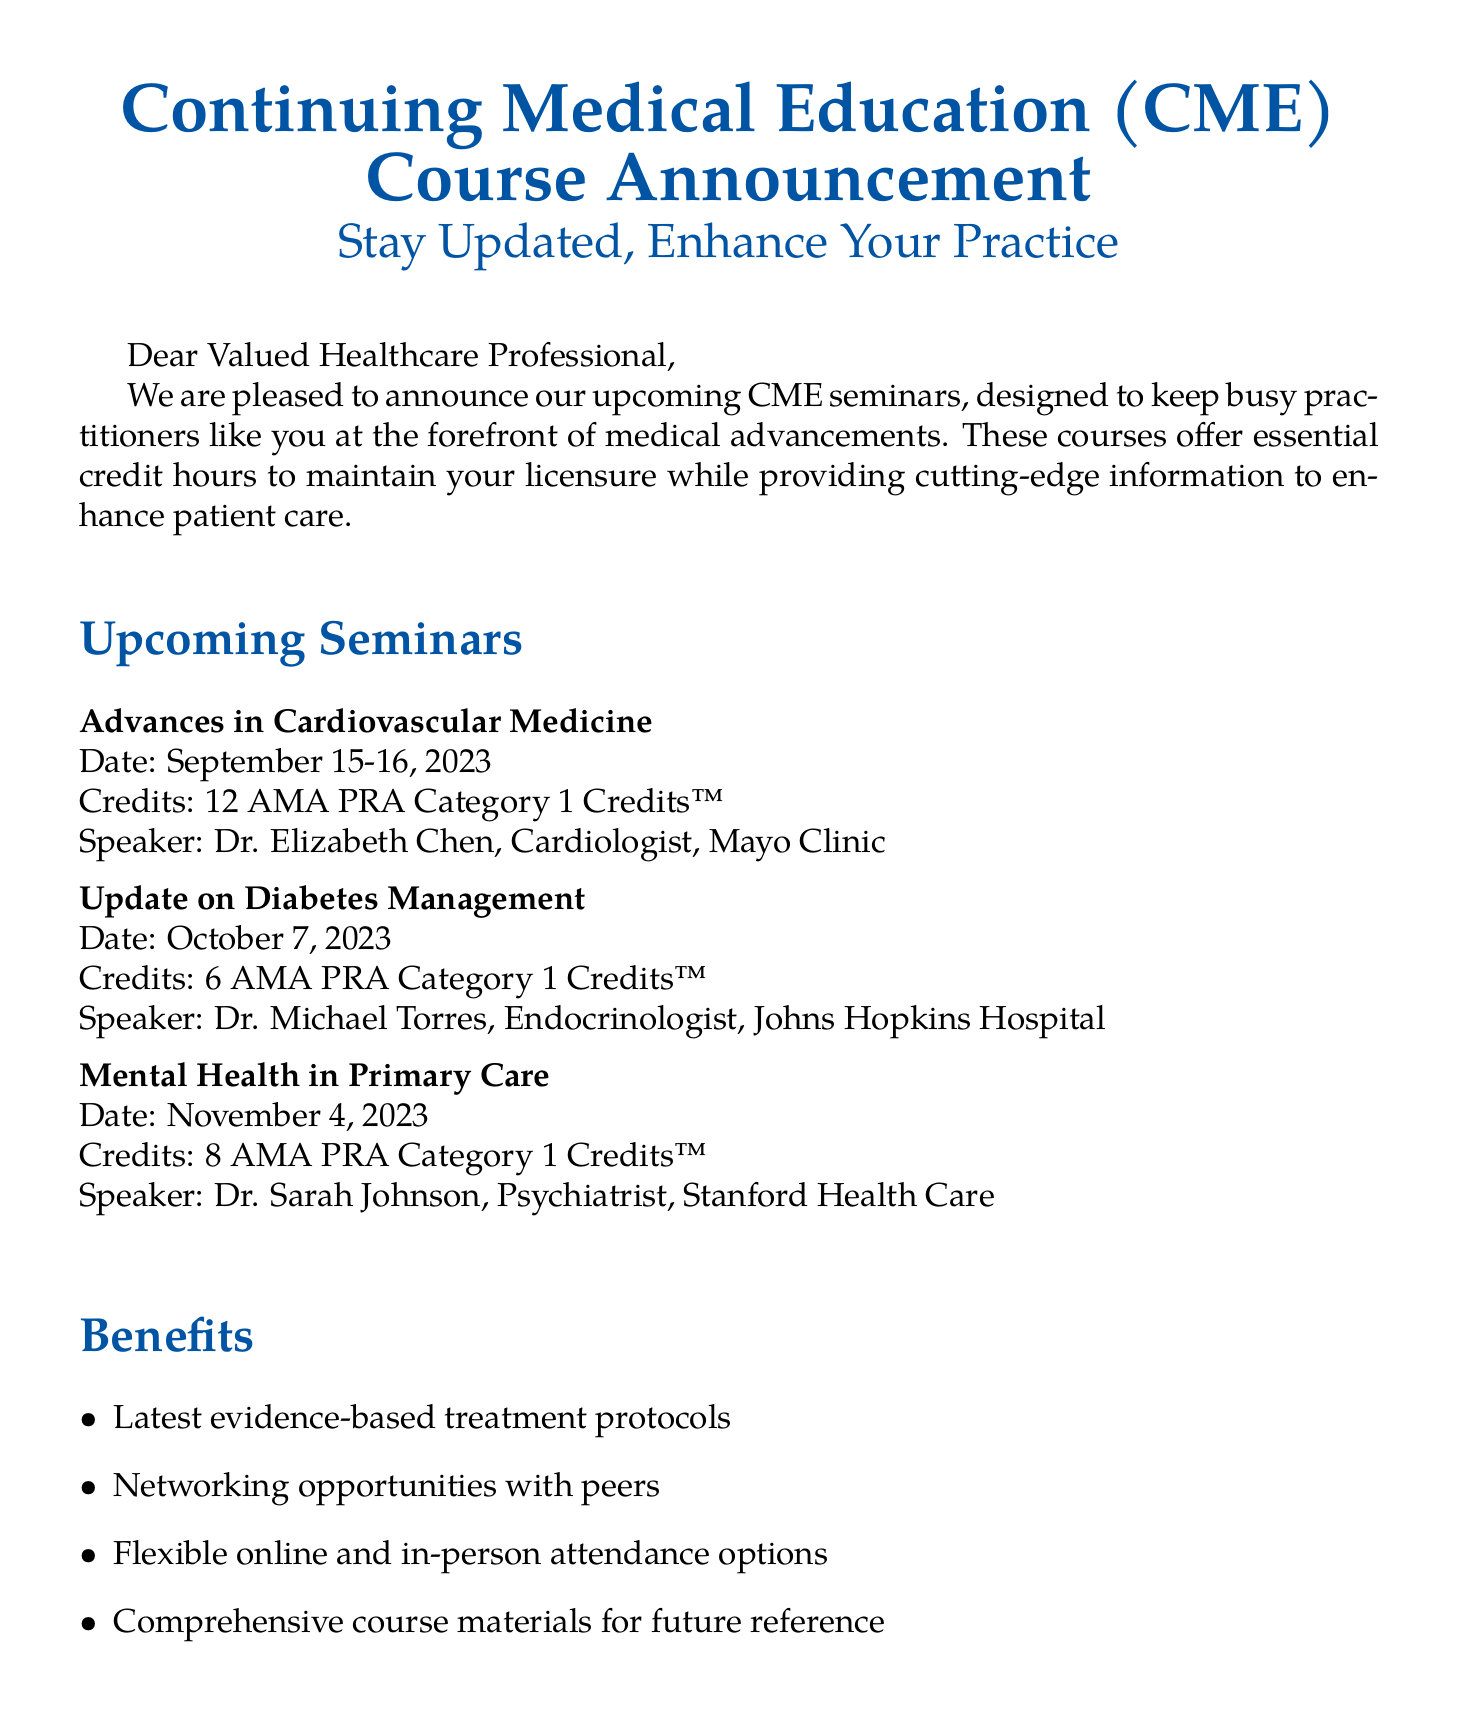What is the title of the first seminar? The first seminar is titled "Advances in Cardiovascular Medicine."
Answer: Advances in Cardiovascular Medicine How many credits does the Diabetes Management seminar offer? The Diabetes Management seminar offers a total of 6 AMA PRA Category 1 Credits™.
Answer: 6 AMA PRA Category 1 Credits™ Who is the speaker for the Mental Health in Primary Care seminar? The speaker for this seminar is Dr. Sarah Johnson, who is a psychiatrist at Stanford Health Care.
Answer: Dr. Sarah Johnson What is the early bird registration deadline? The early bird registration deadline is August 31, 2023.
Answer: August 31, 2023 How many credits are available for the Advances in Cardiovascular Medicine seminar? The seminar provides 12 AMA PRA Category 1 Credits™.
Answer: 12 AMA PRA Category 1 Credits™ What are the flexible attendance options mentioned? The document mentions flexible online and in-person attendance options.
Answer: Online and in-person Which organization is hosting the CME courses? The organization hosting the courses is referenced in the registration information as medicalcme.org.
Answer: medicalcme.org What is the phone number for registration inquiries? The phone number provided for registration inquiries is +1 (800) 555-1234.
Answer: +1 (800) 555-1234 How many seminars are listed in the document? There are three seminars listed in the document.
Answer: Three 